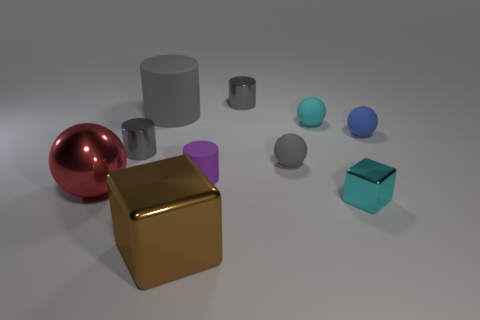Subtract all brown spheres. How many gray cylinders are left? 3 Subtract 2 cylinders. How many cylinders are left? 2 Subtract all cyan cylinders. Subtract all blue balls. How many cylinders are left? 4 Subtract all spheres. How many objects are left? 6 Subtract all small red rubber spheres. Subtract all metal spheres. How many objects are left? 9 Add 8 purple rubber cylinders. How many purple rubber cylinders are left? 9 Add 1 green metallic things. How many green metallic things exist? 1 Subtract 0 red cylinders. How many objects are left? 10 